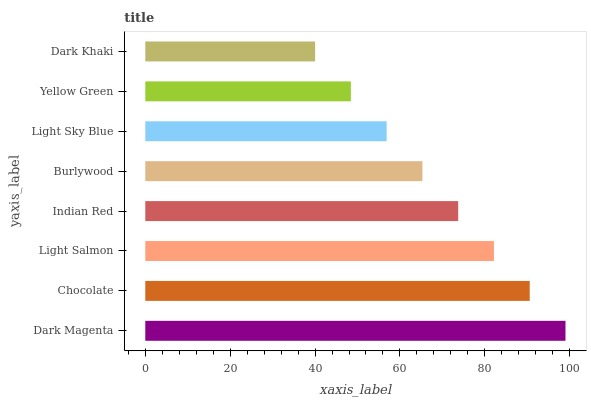Is Dark Khaki the minimum?
Answer yes or no. Yes. Is Dark Magenta the maximum?
Answer yes or no. Yes. Is Chocolate the minimum?
Answer yes or no. No. Is Chocolate the maximum?
Answer yes or no. No. Is Dark Magenta greater than Chocolate?
Answer yes or no. Yes. Is Chocolate less than Dark Magenta?
Answer yes or no. Yes. Is Chocolate greater than Dark Magenta?
Answer yes or no. No. Is Dark Magenta less than Chocolate?
Answer yes or no. No. Is Indian Red the high median?
Answer yes or no. Yes. Is Burlywood the low median?
Answer yes or no. Yes. Is Chocolate the high median?
Answer yes or no. No. Is Yellow Green the low median?
Answer yes or no. No. 